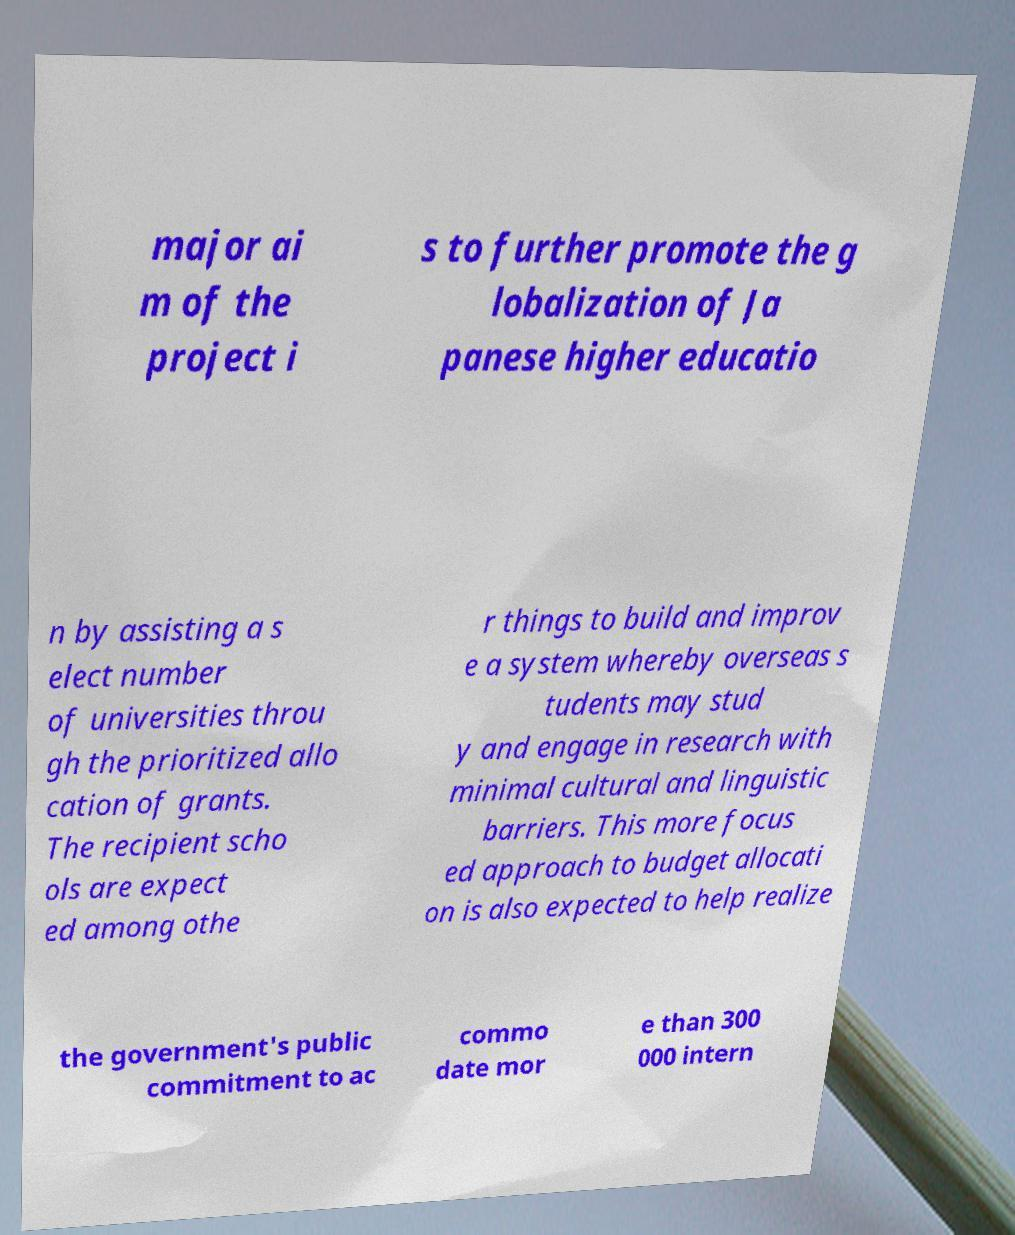I need the written content from this picture converted into text. Can you do that? major ai m of the project i s to further promote the g lobalization of Ja panese higher educatio n by assisting a s elect number of universities throu gh the prioritized allo cation of grants. The recipient scho ols are expect ed among othe r things to build and improv e a system whereby overseas s tudents may stud y and engage in research with minimal cultural and linguistic barriers. This more focus ed approach to budget allocati on is also expected to help realize the government's public commitment to ac commo date mor e than 300 000 intern 